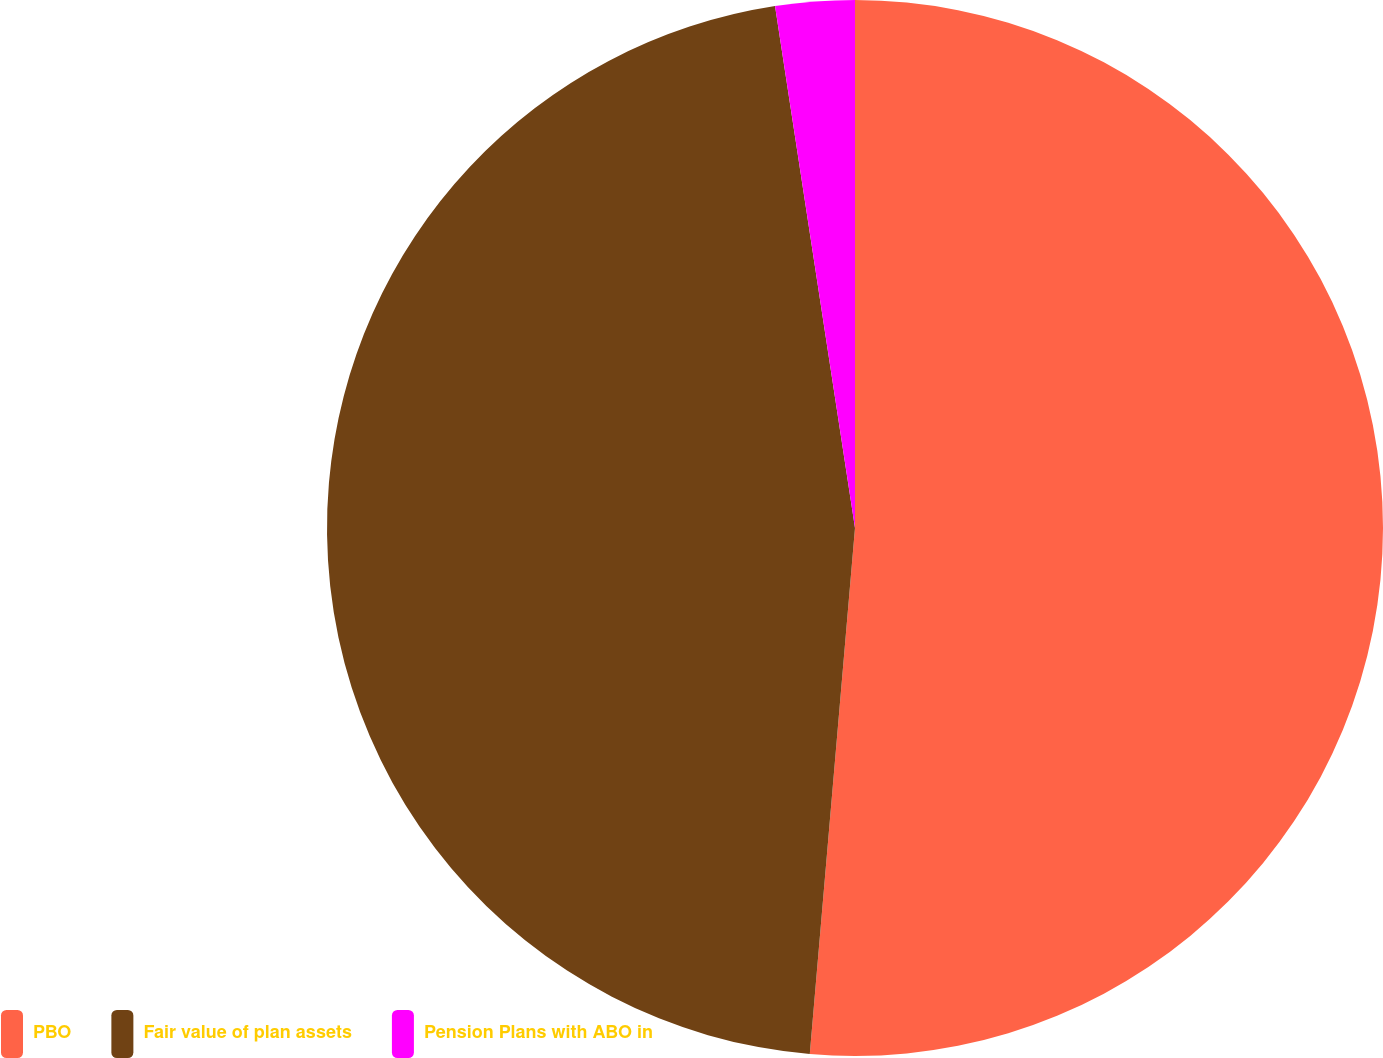Convert chart to OTSL. <chart><loc_0><loc_0><loc_500><loc_500><pie_chart><fcel>PBO<fcel>Fair value of plan assets<fcel>Pension Plans with ABO in<nl><fcel>51.36%<fcel>46.21%<fcel>2.42%<nl></chart> 